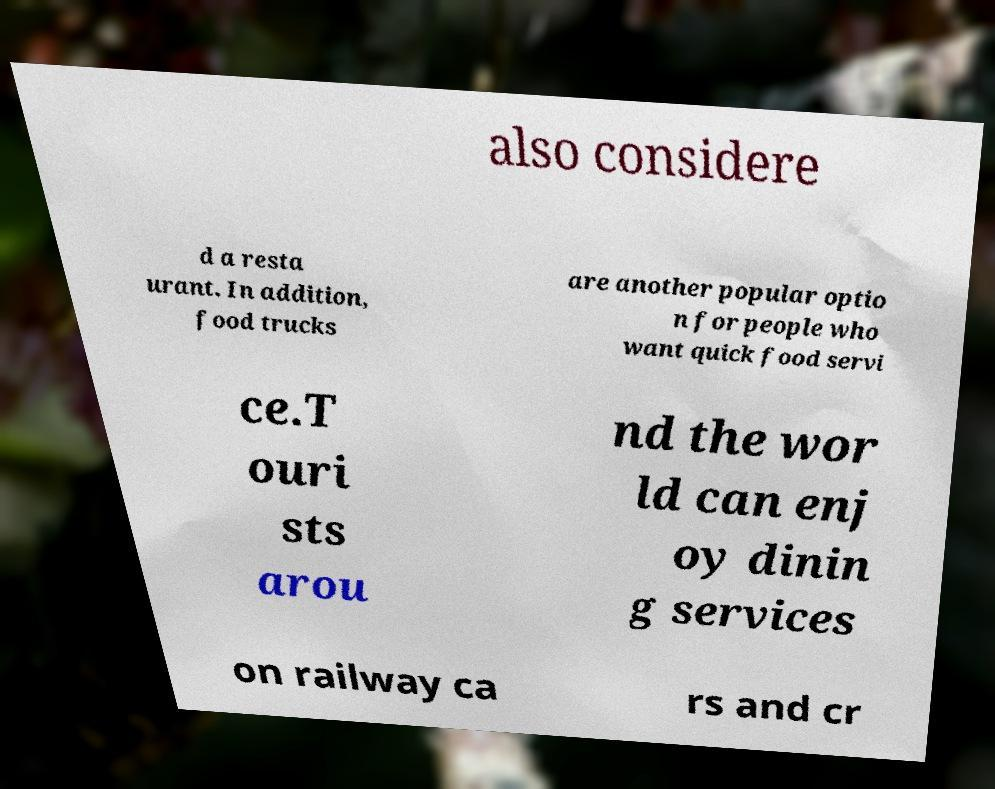There's text embedded in this image that I need extracted. Can you transcribe it verbatim? also considere d a resta urant. In addition, food trucks are another popular optio n for people who want quick food servi ce.T ouri sts arou nd the wor ld can enj oy dinin g services on railway ca rs and cr 